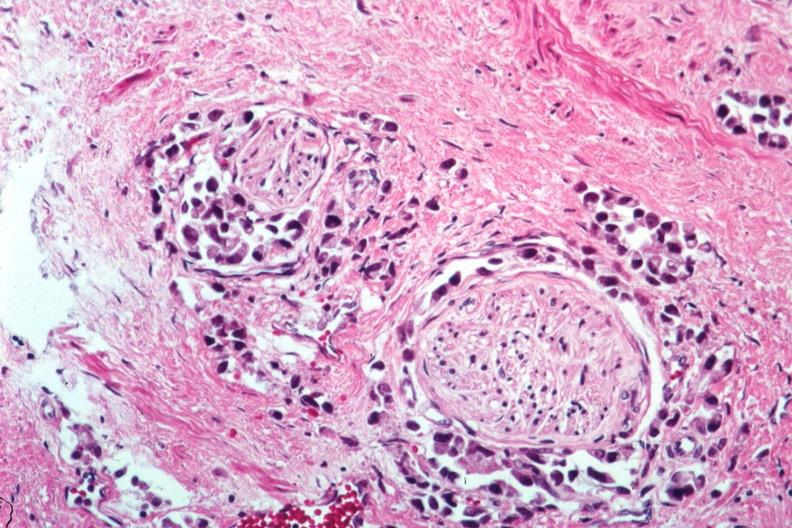what is present?
Answer the question using a single word or phrase. Adenocarcinoma 